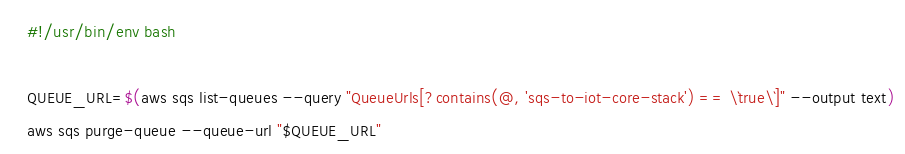<code> <loc_0><loc_0><loc_500><loc_500><_Bash_>#!/usr/bin/env bash

QUEUE_URL=$(aws sqs list-queues --query "QueueUrls[?contains(@, 'sqs-to-iot-core-stack') == \`true\`]" --output text)
aws sqs purge-queue --queue-url "$QUEUE_URL"
</code> 